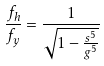Convert formula to latex. <formula><loc_0><loc_0><loc_500><loc_500>\frac { f _ { h } } { f _ { y } } = \frac { 1 } { \sqrt { 1 - \frac { s ^ { 5 } } { g ^ { 5 } } } }</formula> 